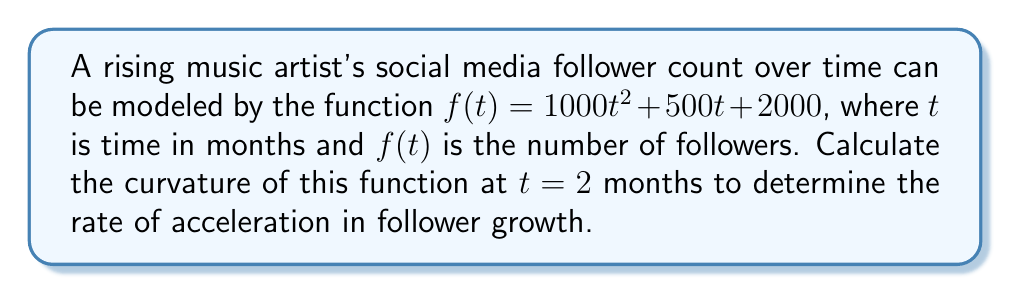Help me with this question. To find the curvature of the function at a specific point, we'll use the formula:

$$\kappa = \frac{|f''(t)|}{(1 + [f'(t)]^2)^{3/2}}$$

Step 1: Find $f'(t)$ and $f''(t)$
$f'(t) = 2000t + 500$
$f''(t) = 2000$

Step 2: Evaluate $f'(t)$ at $t = 2$
$f'(2) = 2000(2) + 500 = 4500$

Step 3: Substitute values into the curvature formula
$$\kappa = \frac{|2000|}{(1 + [4500]^2)^{3/2}}$$

Step 4: Simplify
$$\kappa = \frac{2000}{(1 + 20250000)^{3/2}}$$
$$\kappa = \frac{2000}{20250001^{3/2}}$$

Step 5: Calculate the final value
$$\kappa \approx 1.9606 \times 10^{-7}$$

This small positive curvature indicates a gradual acceleration in follower growth at $t = 2$ months.
Answer: $1.9606 \times 10^{-7}$ 